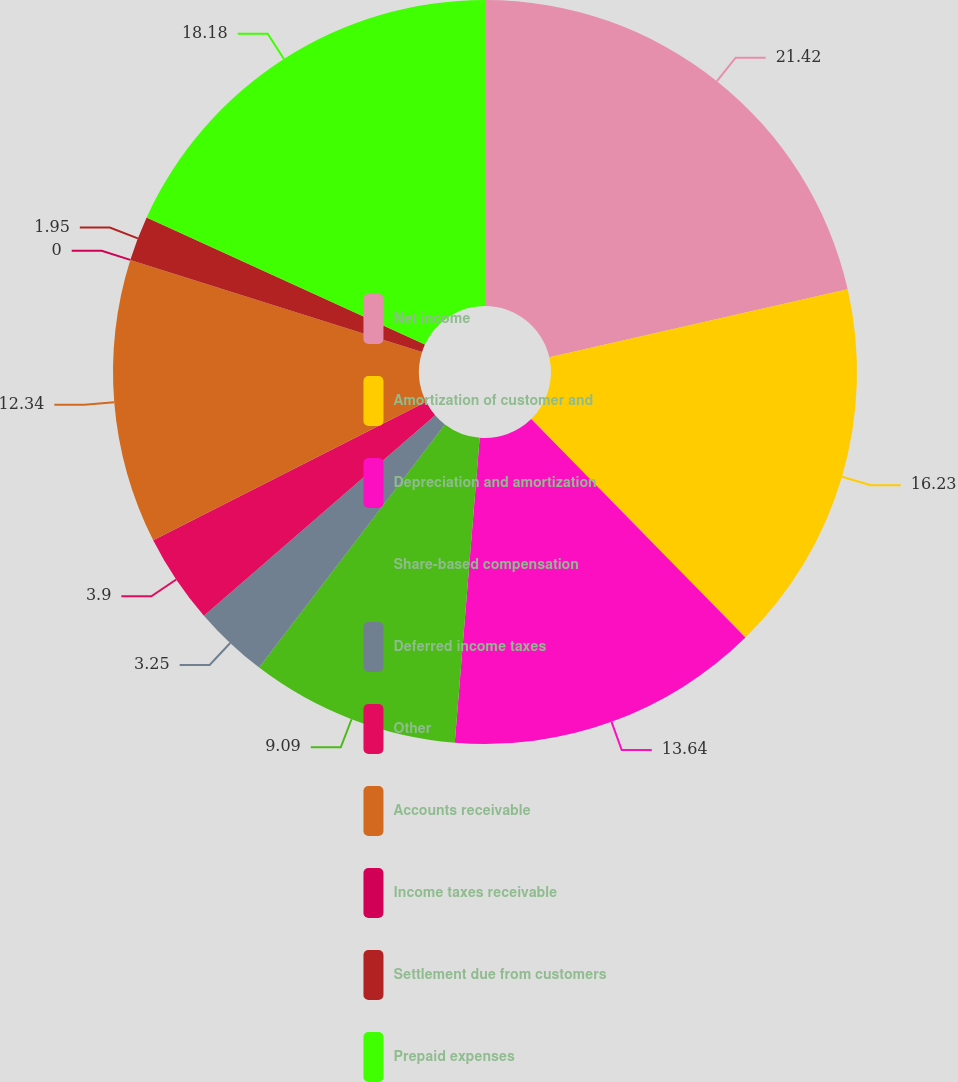Convert chart to OTSL. <chart><loc_0><loc_0><loc_500><loc_500><pie_chart><fcel>Net income<fcel>Amortization of customer and<fcel>Depreciation and amortization<fcel>Share-based compensation<fcel>Deferred income taxes<fcel>Other<fcel>Accounts receivable<fcel>Income taxes receivable<fcel>Settlement due from customers<fcel>Prepaid expenses<nl><fcel>21.43%<fcel>16.23%<fcel>13.64%<fcel>9.09%<fcel>3.25%<fcel>3.9%<fcel>12.34%<fcel>0.0%<fcel>1.95%<fcel>18.18%<nl></chart> 